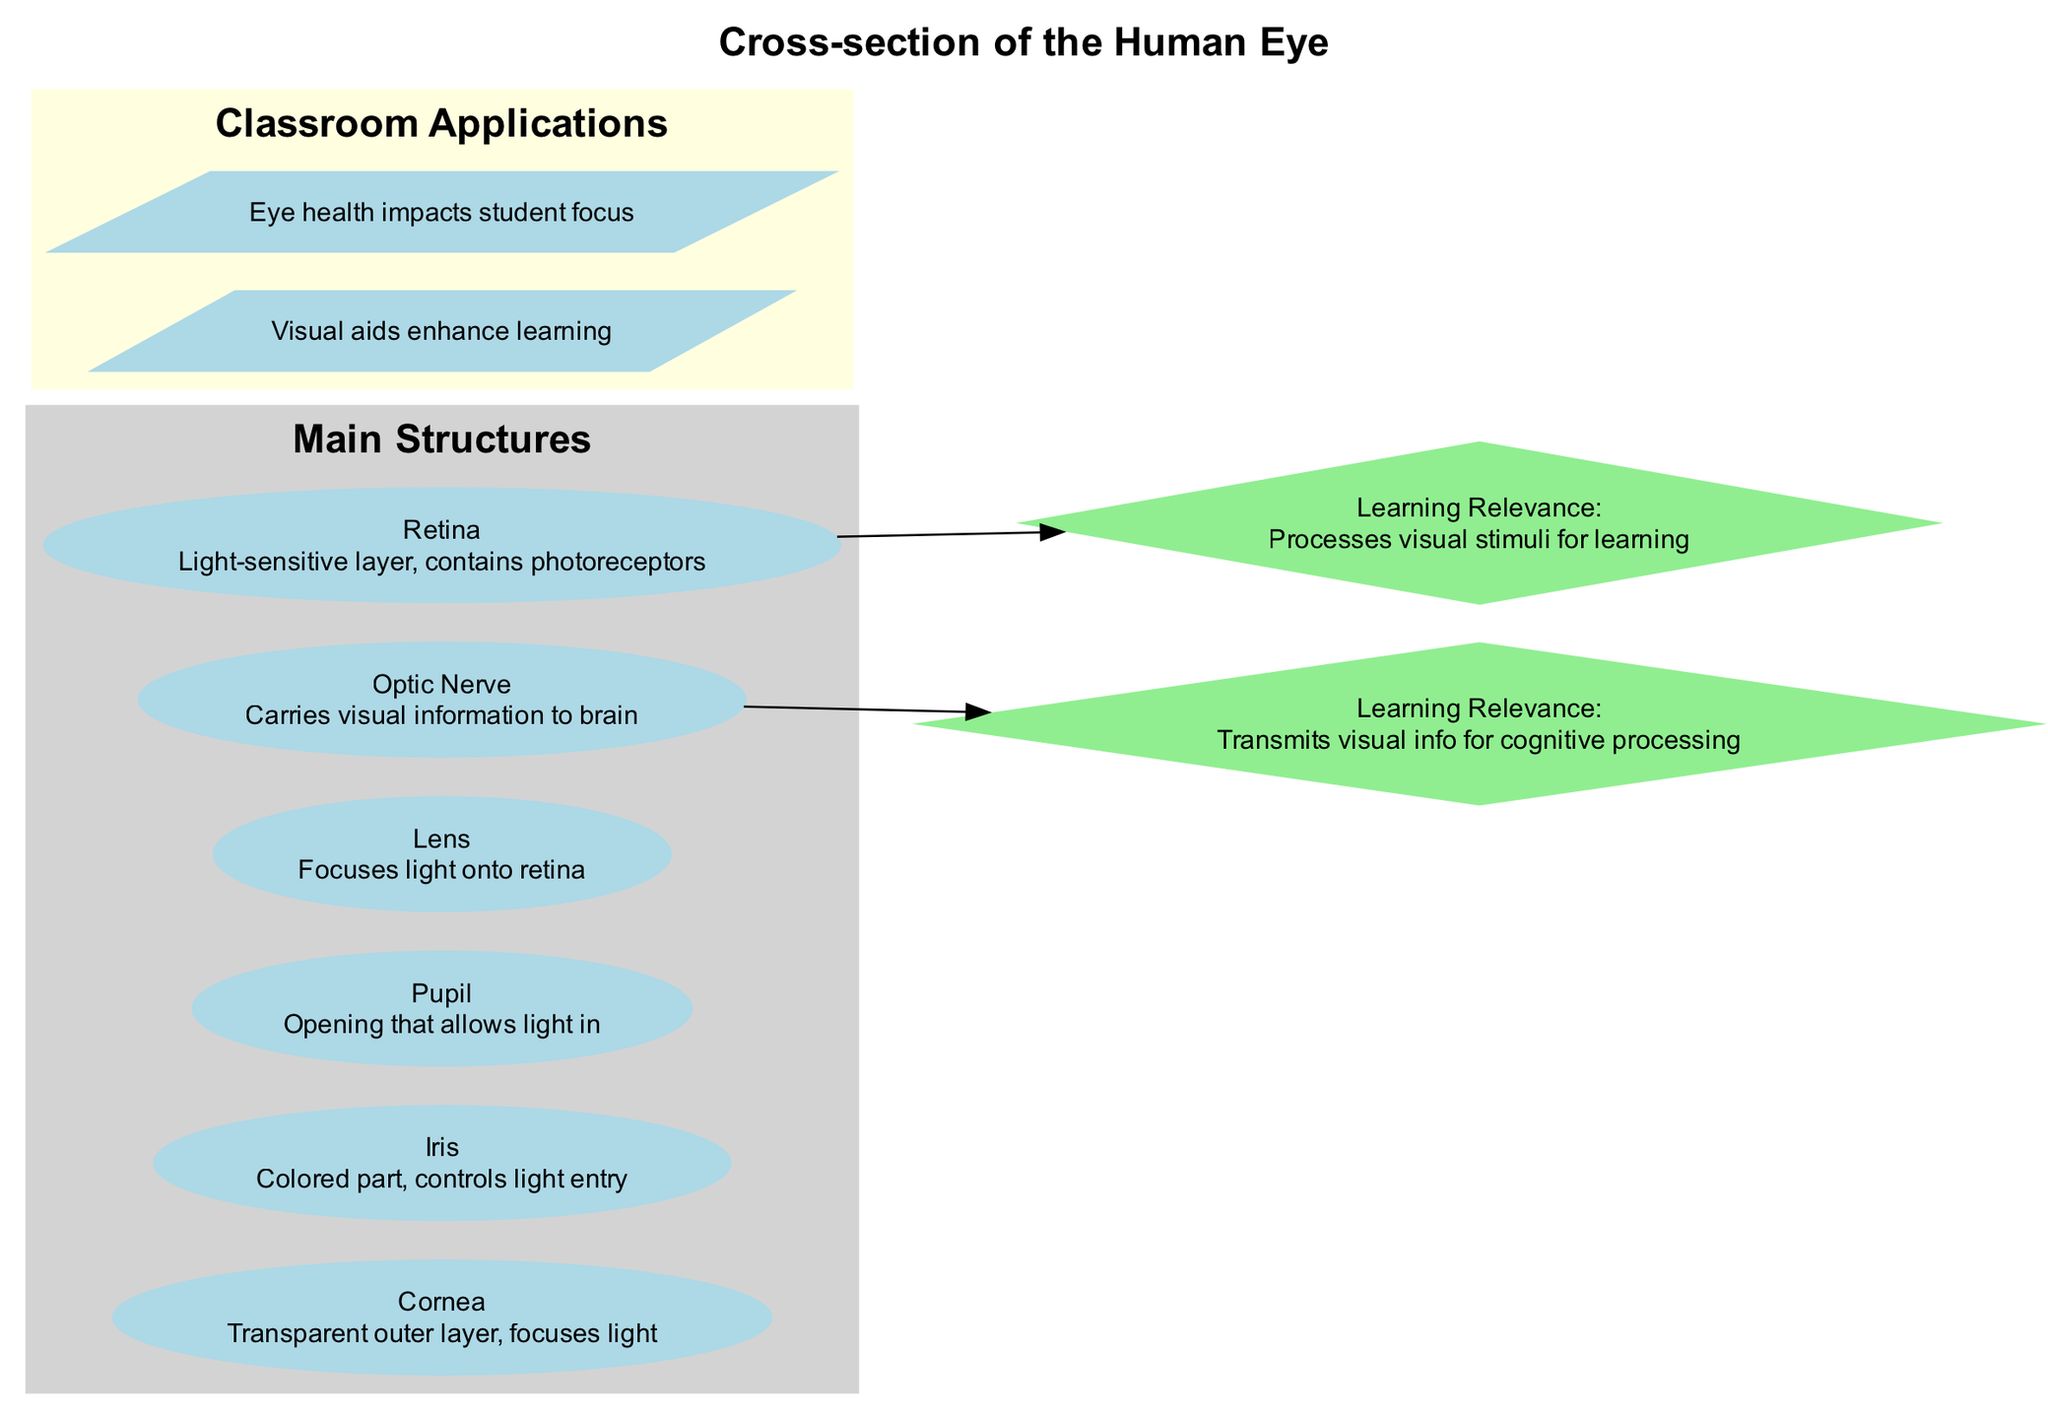What is the outer layer of the eye called? The diagram labels the outer layer of the eye as "Cornea." This is a well-defined structure in the visual representation, making it straightforward to identify its name.
Answer: Cornea How many main structures are illustrated in the diagram? The diagram clearly lists six main structures, which are outlined in the "Main Structures" section. By counting these, we can ascertain the total number.
Answer: 6 What is the function of the lens? According to the detailed element description in the diagram, the lens is responsible for "Focuses light onto retina." Thus, this concise description captures its primary function.
Answer: Focuses light onto retina Which structure processes visual information for learning? The diagram indicates that the "Retina" processes visual stimuli for learning, under the learning relevance section. This highlights the connection between this eye structure and its role in visual information processing.
Answer: Retina What controls the amount of light entering the eye? The diagram specifies that the "Iris" is responsible for controlling light entry. This is clearly identified in the descriptions provided for the eye's detailed elements, indicating its role in managing light exposure.
Answer: Iris How does the optic nerve contribute to cognition? The diagram mentions that the "Optic Nerve" transmits visual information for cognitive processing. It implies that the nerve's function is essential for the brain's interpretation of visual data, outlining its pivotal role in cognition.
Answer: Transmits visual info for cognitive processing Which element is colored and a part of the eye? In the diagram, the "Iris" is explicitly described as the "Colored part," distinguishing it from other components and confirming its identity as the colored feature of the eye.
Answer: Iris What are visual aids believed to impact in the classroom? One of the classroom applications in the diagram directly states that "Visual aids enhance learning," indicating a strong correlation between the use of visual tools and the improvement of learning outcomes in students.
Answer: Enhance learning What shape is used to represent the detailed elements? The diagram uses the "ellipse" shape to represent detailed elements, as stated in the rendering instructions. This establishes a specific visual representation and organization of the information provided about these components.
Answer: Ellipse 